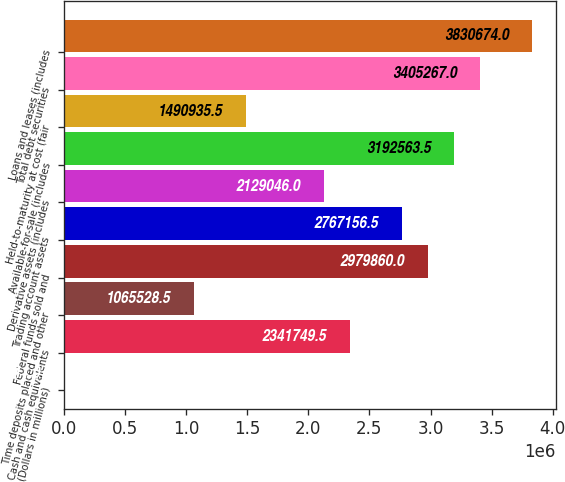Convert chart. <chart><loc_0><loc_0><loc_500><loc_500><bar_chart><fcel>(Dollars in millions)<fcel>Cash and cash equivalents<fcel>Time deposits placed and other<fcel>Federal funds sold and<fcel>Trading account assets<fcel>Derivative assets (includes<fcel>Available-for-sale (includes<fcel>Held-to-maturity at cost (fair<fcel>Total debt securities<fcel>Loans and leases (includes<nl><fcel>2011<fcel>2.34175e+06<fcel>1.06553e+06<fcel>2.97986e+06<fcel>2.76716e+06<fcel>2.12905e+06<fcel>3.19256e+06<fcel>1.49094e+06<fcel>3.40527e+06<fcel>3.83067e+06<nl></chart> 